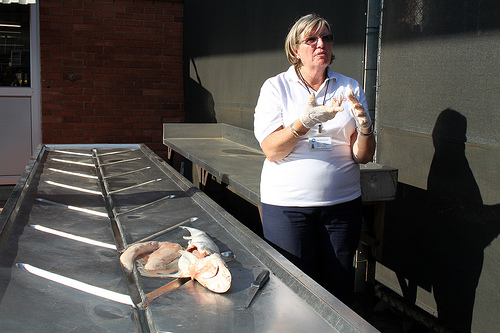<image>
Is there a shadow to the left of the woman? No. The shadow is not to the left of the woman. From this viewpoint, they have a different horizontal relationship. 